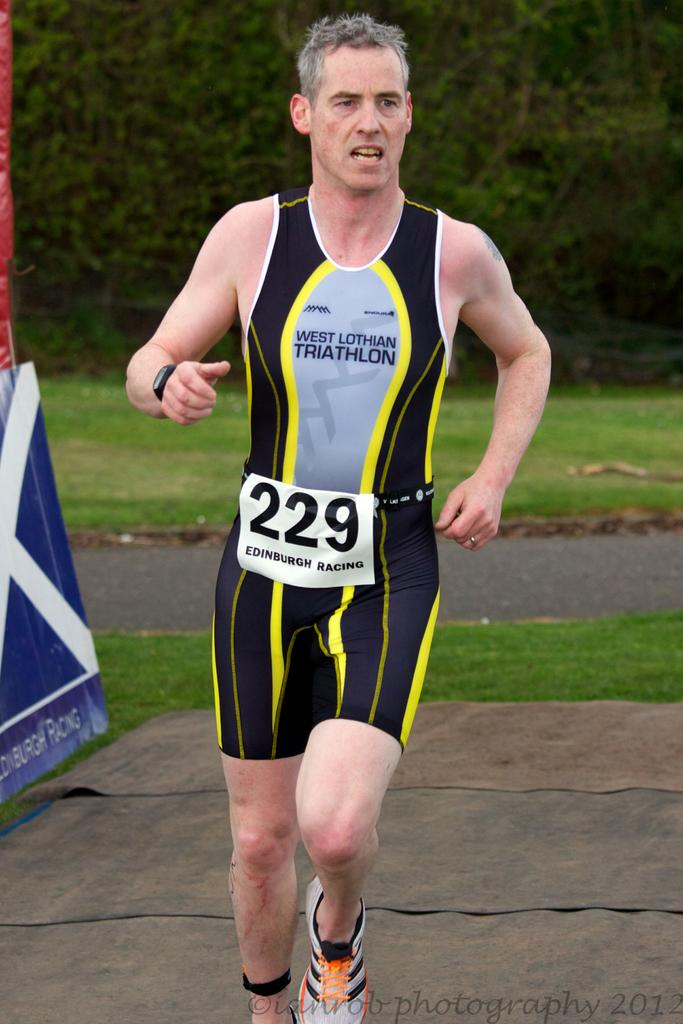What is the man in the image doing? The man is running in the image. What type of terrain is visible in the image? There is grass visible in the image. What other natural elements can be seen in the image? There are trees in the image. What is located on the left side of the image? There is a banner on the left side of the image. What type of appliance is being used by the army in the image? There is no army or appliance present in the image; it features a man running in a grassy area with trees and a banner. What type of laborer is working on the trees in the image? There are no laborers or tree-related work visible in the image; it only shows a man running, grass, trees, and a banner. 